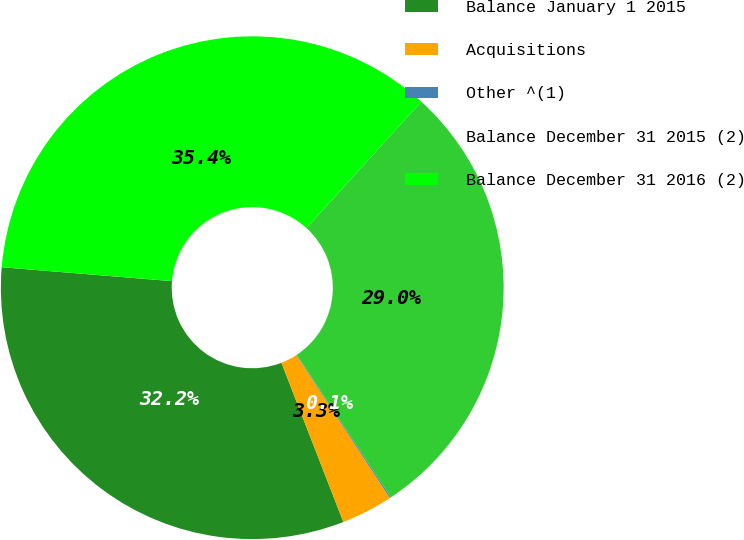Convert chart to OTSL. <chart><loc_0><loc_0><loc_500><loc_500><pie_chart><fcel>Balance January 1 2015<fcel>Acquisitions<fcel>Other ^(1)<fcel>Balance December 31 2015 (2)<fcel>Balance December 31 2016 (2)<nl><fcel>32.2%<fcel>3.32%<fcel>0.08%<fcel>28.96%<fcel>35.44%<nl></chart> 